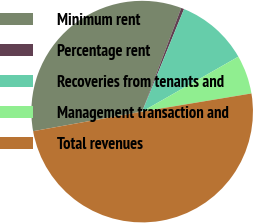Convert chart to OTSL. <chart><loc_0><loc_0><loc_500><loc_500><pie_chart><fcel>Minimum rent<fcel>Percentage rent<fcel>Recoveries from tenants and<fcel>Management transaction and<fcel>Total revenues<nl><fcel>33.57%<fcel>0.43%<fcel>10.57%<fcel>5.64%<fcel>49.79%<nl></chart> 